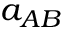<formula> <loc_0><loc_0><loc_500><loc_500>a _ { A B }</formula> 